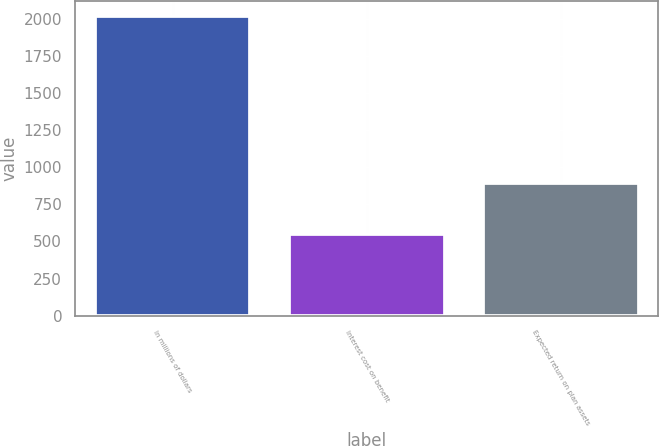<chart> <loc_0><loc_0><loc_500><loc_500><bar_chart><fcel>In millions of dollars<fcel>Interest cost on benefit<fcel>Expected return on plan assets<nl><fcel>2015<fcel>553<fcel>893<nl></chart> 